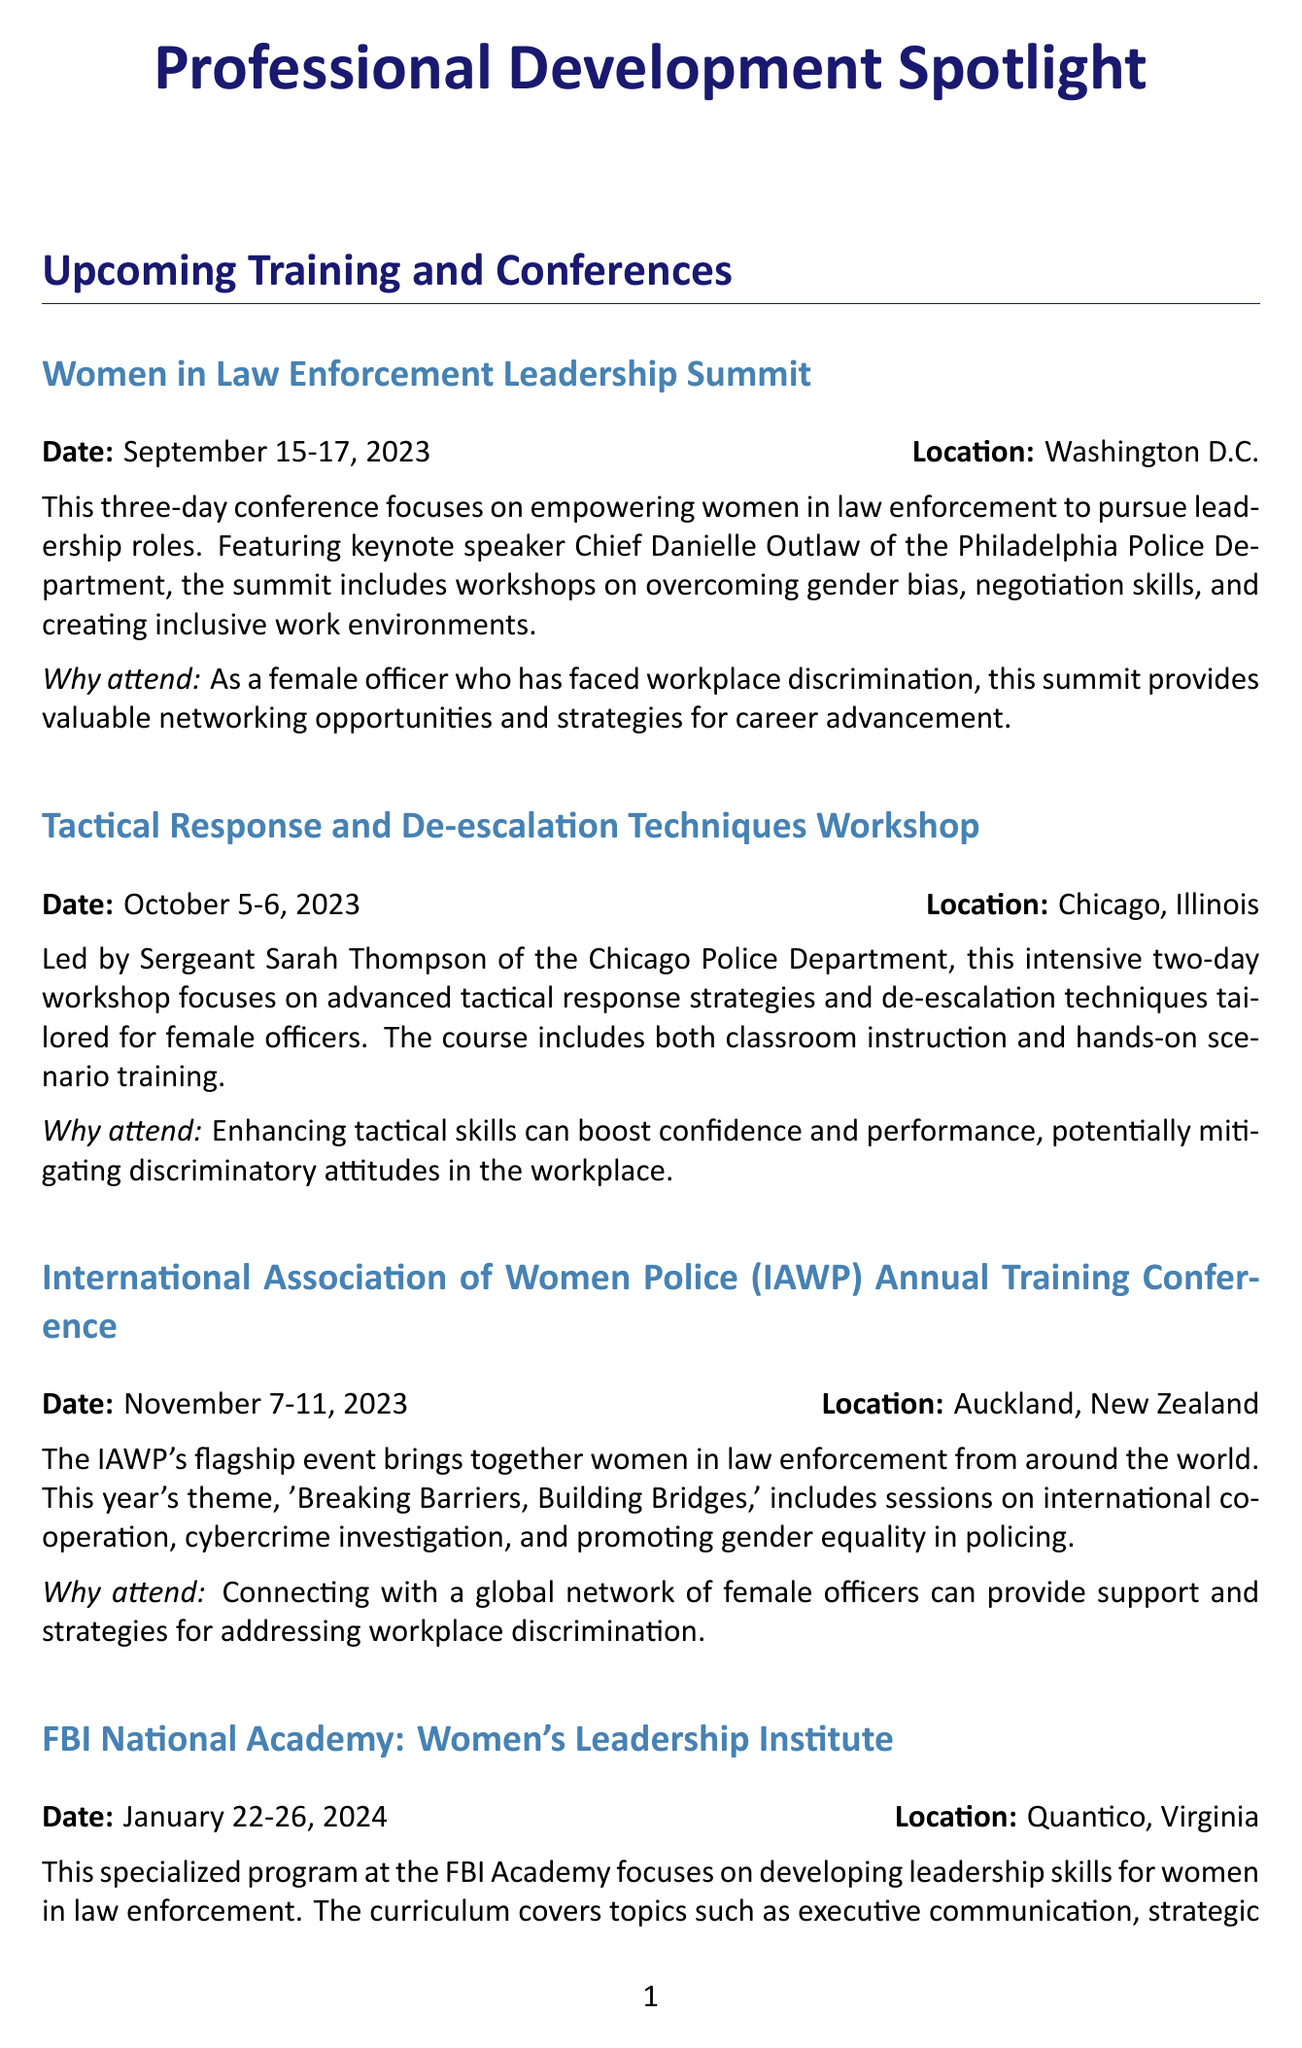What is the date of the Women in Law Enforcement Leadership Summit? The date is clearly mentioned in the document for the summit, which is September 15-17, 2023.
Answer: September 15-17, 2023 Who is the keynote speaker at the Women in Law Enforcement Leadership Summit? The keynote speaker's name is provided in the summit details, which is Chief Danielle Outlaw.
Answer: Chief Danielle Outlaw Where is the International Association of Women Police Annual Training Conference being held? The location is specified in the conference details as Auckland, New Zealand.
Answer: Auckland, New Zealand What is the main focus of the Tactical Response and De-escalation Techniques Workshop? The focus is outlined in the workshop description, which is on advanced tactical response strategies and de-escalation techniques for female officers.
Answer: Advanced tactical response strategies and de-escalation techniques When is the application deadline for the Women's Law Enforcement Mentorship Program? The timeframe for applications is stated, indicating they are open now for the 2024 cohort.
Answer: Now (for 2024 cohort) What theme is being discussed at the IAWP Annual Training Conference? The theme is mentioned in the conference details, which is "Breaking Barriers, Building Bridges."
Answer: Breaking Barriers, Building Bridges How long is the FBI National Academy Women's Leadership Institute program? The duration is specified in the document, stating that it takes place over five days.
Answer: Five days What type of event is the Trauma-Informed Policing session? The document categorizes this as an online webinar.
Answer: Online Webinar 